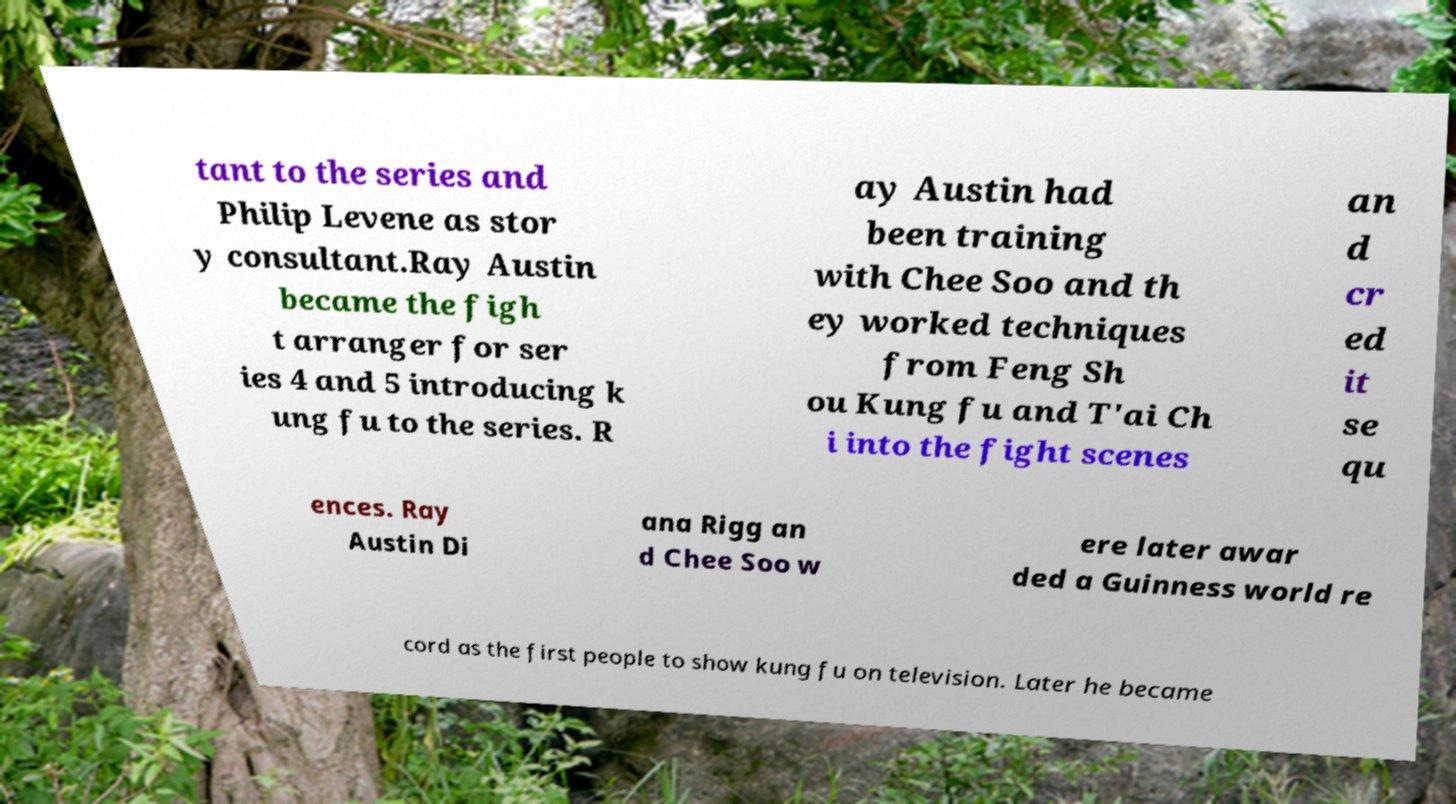Please read and relay the text visible in this image. What does it say? tant to the series and Philip Levene as stor y consultant.Ray Austin became the figh t arranger for ser ies 4 and 5 introducing k ung fu to the series. R ay Austin had been training with Chee Soo and th ey worked techniques from Feng Sh ou Kung fu and T'ai Ch i into the fight scenes an d cr ed it se qu ences. Ray Austin Di ana Rigg an d Chee Soo w ere later awar ded a Guinness world re cord as the first people to show kung fu on television. Later he became 